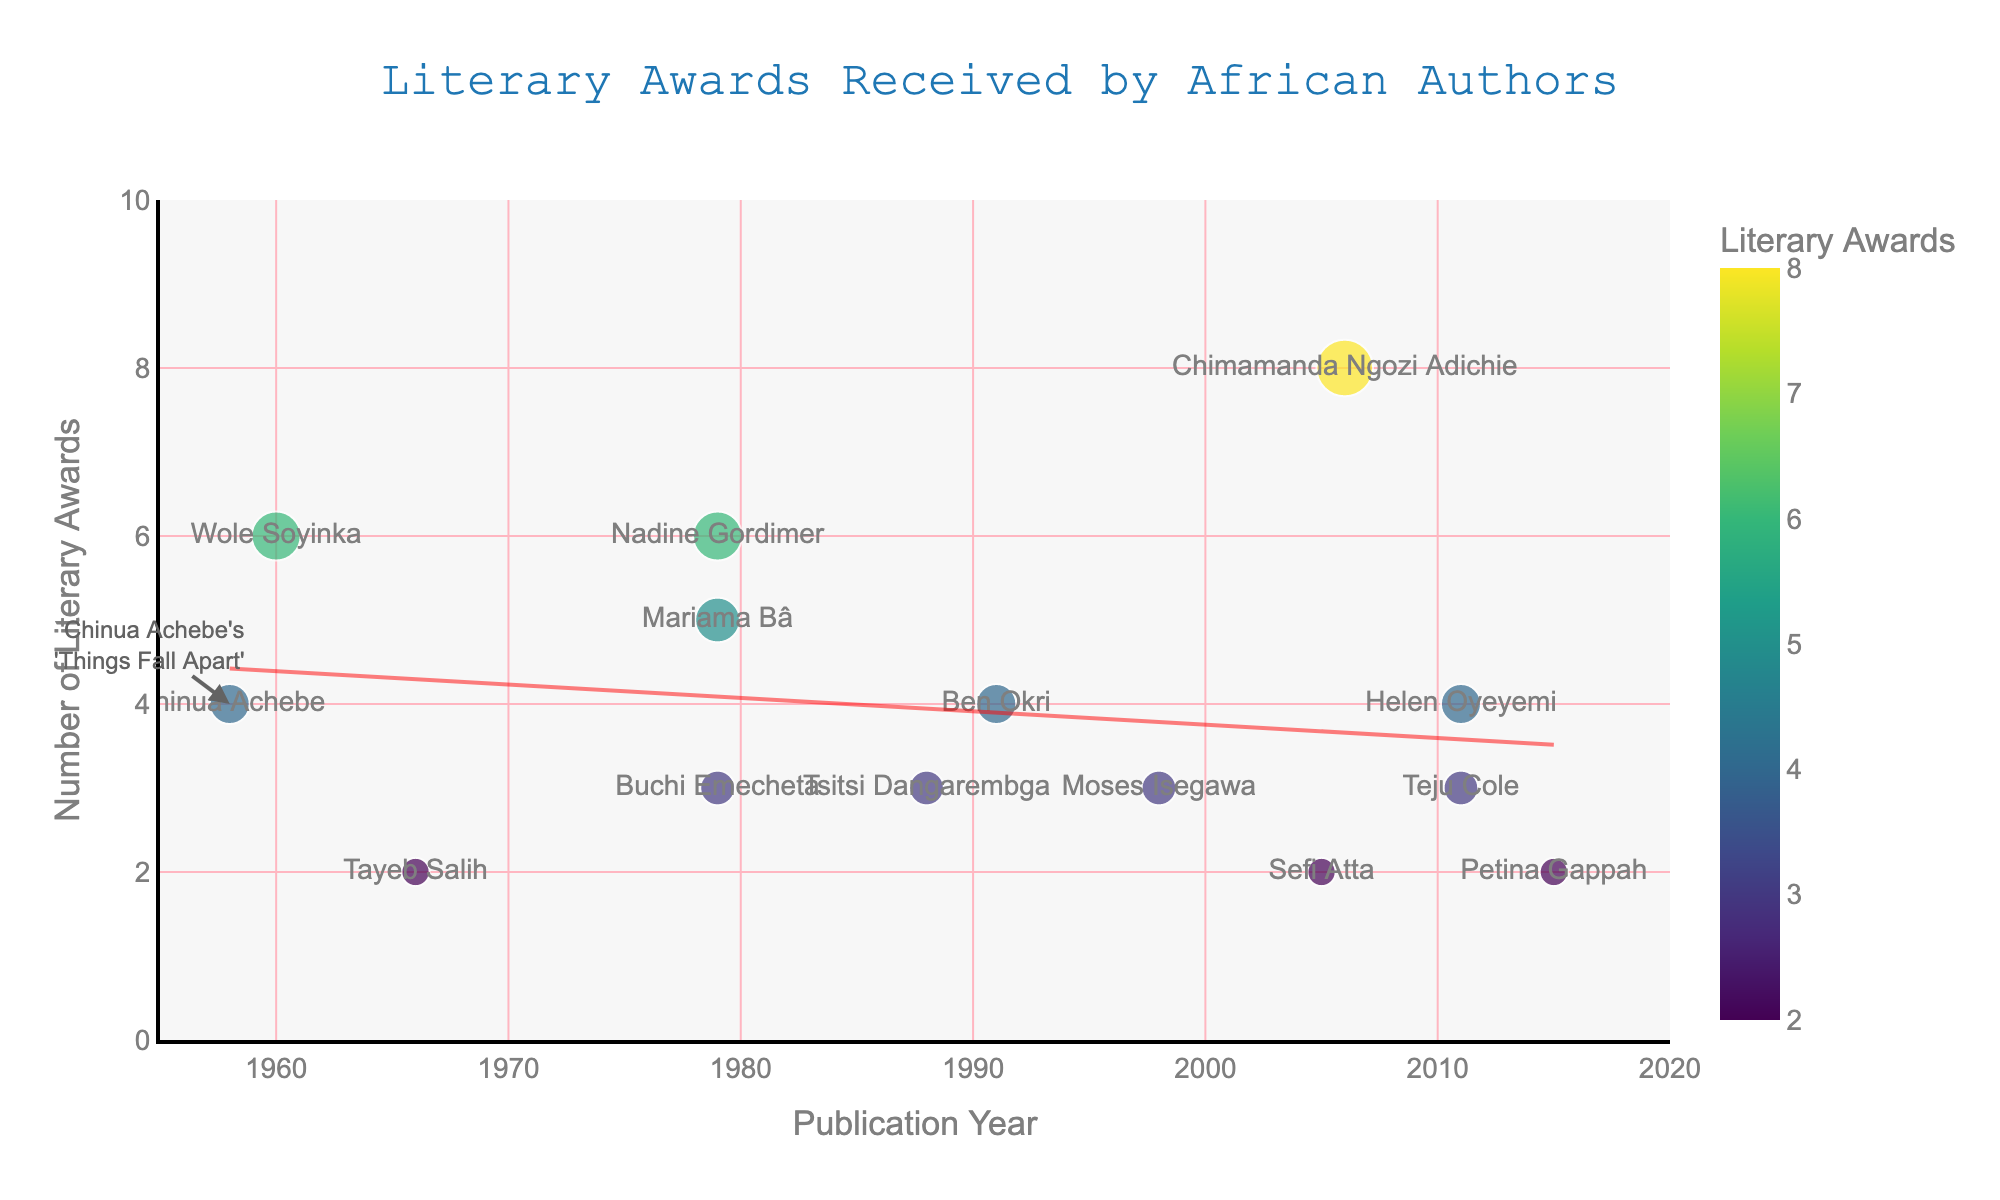Which year had the highest number of literary awards? We simply look at the data points on the y-axis and note the corresponding x-axis year value for the highest y-value. The highest number of literary awards is 8 in the year 2006, corresponding to Chimamanda Ngozi Adichie's 'Half of a Yellow Sun'.
Answer: 2006 What is the overall trend line showing regarding the number of literary awards over the years? By observing the trend line added to the scatter plot, we can see whether it slopes upwards or downwards. An upward slope indicates an increasing trend over the years. Here, the trend line slopes upward, suggesting that the number of literary awards received by African authors increases over the years.
Answer: Increasing Which authors had the same number of literary awards for their works published in 1979? We identify the data points corresponding to works published in 1979 and compare their y-values. Mariama Bâ and Buchi Emecheta both published works in 1979 and received 5 and 3 awards respectively, but the same number of awards applies to Nadine Gordimer, who also published in 1979 and received 6 awards.
Answer: None How many authors published their major works between 1980 and 2000? Count the data points along the x-axis between 1980 and 2000. These include works by Tsitsi Dangarembga (1988), Ben Okri (1991), and Moses Isegawa (1998), which total 3 authors.
Answer: 3 What is the difference in the number of literary awards between 'Things Fall Apart' and 'A Dance of the Forests'? Find the y-values for the respective works and subtract them: 'Things Fall Apart' (1958) received 4 awards and 'A Dance of the Forests' (1960) received 6 awards, so the difference is 6 - 4.
Answer: 2 Which work has the maximum y-value, and what does this imply? The maximum y-value represents the highest number of literary awards received. By spotting the highest data point, we note that it's corresponding to Chimamanda Ngozi Adichie’s 'Half of a Yellow Sun' with 8 awards. This implies it's the most awarded major work in the dataset.
Answer: Half of a Yellow Sun Among the works published in or after 2000, which had the least number of literary awards? Out of the works published from 2000 onwards, compare the y-values: 'Everything Good Will Come' (2 awards published in 2005), 'Open City' (3 awards in 2011), 'Mr. Fox' (4 awards in 2011), and 'The Book of Memory' (2 awards in 2015). Both 'Everything Good Will Come' and 'The Book of Memory' have the least with 2 awards.
Answer: Everything Good Will Come and The Book of Memory Do more recent works (post-2000) generally receive more literary awards compared to earlier works? Compare the y-values of works published post-2000 with those published prior. Post-2000 works tend to have a greater number of awards (3, 4, 2, 3, and 8 in contrast to earlier works mostly clustered around 2 to 6 awards, confirming this trend to some extent. The trend line also supports this observation.
Answer: Yes Which two authors published major works in the same year and how many awards did they get? Identify the year with multiple data points on the x-axis and check those points' y-values. In 2011, both Helen Oyeyemi and Teju Cole have major works 'Mr. Fox' and 'Open City' with 4 and 3 awards respectively.
Answer: Helen Oyeyemi and Teju Cole: 4 and 3 awards respectively 